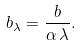<formula> <loc_0><loc_0><loc_500><loc_500>b _ { \lambda } = \frac { b } { \alpha \, \lambda } .</formula> 